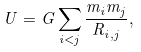<formula> <loc_0><loc_0><loc_500><loc_500>U = G \sum _ { i < j } \frac { m _ { i } m _ { j } } { R _ { i , j } } ,</formula> 